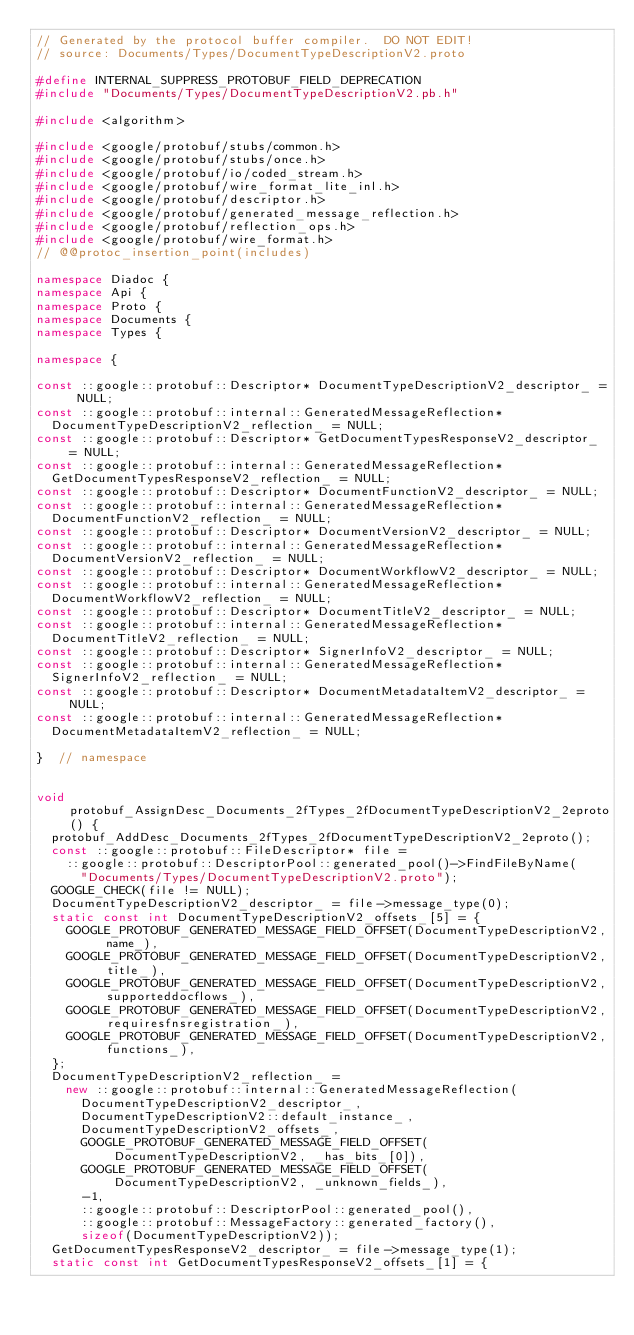Convert code to text. <code><loc_0><loc_0><loc_500><loc_500><_C++_>// Generated by the protocol buffer compiler.  DO NOT EDIT!
// source: Documents/Types/DocumentTypeDescriptionV2.proto

#define INTERNAL_SUPPRESS_PROTOBUF_FIELD_DEPRECATION
#include "Documents/Types/DocumentTypeDescriptionV2.pb.h"

#include <algorithm>

#include <google/protobuf/stubs/common.h>
#include <google/protobuf/stubs/once.h>
#include <google/protobuf/io/coded_stream.h>
#include <google/protobuf/wire_format_lite_inl.h>
#include <google/protobuf/descriptor.h>
#include <google/protobuf/generated_message_reflection.h>
#include <google/protobuf/reflection_ops.h>
#include <google/protobuf/wire_format.h>
// @@protoc_insertion_point(includes)

namespace Diadoc {
namespace Api {
namespace Proto {
namespace Documents {
namespace Types {

namespace {

const ::google::protobuf::Descriptor* DocumentTypeDescriptionV2_descriptor_ = NULL;
const ::google::protobuf::internal::GeneratedMessageReflection*
  DocumentTypeDescriptionV2_reflection_ = NULL;
const ::google::protobuf::Descriptor* GetDocumentTypesResponseV2_descriptor_ = NULL;
const ::google::protobuf::internal::GeneratedMessageReflection*
  GetDocumentTypesResponseV2_reflection_ = NULL;
const ::google::protobuf::Descriptor* DocumentFunctionV2_descriptor_ = NULL;
const ::google::protobuf::internal::GeneratedMessageReflection*
  DocumentFunctionV2_reflection_ = NULL;
const ::google::protobuf::Descriptor* DocumentVersionV2_descriptor_ = NULL;
const ::google::protobuf::internal::GeneratedMessageReflection*
  DocumentVersionV2_reflection_ = NULL;
const ::google::protobuf::Descriptor* DocumentWorkflowV2_descriptor_ = NULL;
const ::google::protobuf::internal::GeneratedMessageReflection*
  DocumentWorkflowV2_reflection_ = NULL;
const ::google::protobuf::Descriptor* DocumentTitleV2_descriptor_ = NULL;
const ::google::protobuf::internal::GeneratedMessageReflection*
  DocumentTitleV2_reflection_ = NULL;
const ::google::protobuf::Descriptor* SignerInfoV2_descriptor_ = NULL;
const ::google::protobuf::internal::GeneratedMessageReflection*
  SignerInfoV2_reflection_ = NULL;
const ::google::protobuf::Descriptor* DocumentMetadataItemV2_descriptor_ = NULL;
const ::google::protobuf::internal::GeneratedMessageReflection*
  DocumentMetadataItemV2_reflection_ = NULL;

}  // namespace


void protobuf_AssignDesc_Documents_2fTypes_2fDocumentTypeDescriptionV2_2eproto() {
  protobuf_AddDesc_Documents_2fTypes_2fDocumentTypeDescriptionV2_2eproto();
  const ::google::protobuf::FileDescriptor* file =
    ::google::protobuf::DescriptorPool::generated_pool()->FindFileByName(
      "Documents/Types/DocumentTypeDescriptionV2.proto");
  GOOGLE_CHECK(file != NULL);
  DocumentTypeDescriptionV2_descriptor_ = file->message_type(0);
  static const int DocumentTypeDescriptionV2_offsets_[5] = {
    GOOGLE_PROTOBUF_GENERATED_MESSAGE_FIELD_OFFSET(DocumentTypeDescriptionV2, name_),
    GOOGLE_PROTOBUF_GENERATED_MESSAGE_FIELD_OFFSET(DocumentTypeDescriptionV2, title_),
    GOOGLE_PROTOBUF_GENERATED_MESSAGE_FIELD_OFFSET(DocumentTypeDescriptionV2, supporteddocflows_),
    GOOGLE_PROTOBUF_GENERATED_MESSAGE_FIELD_OFFSET(DocumentTypeDescriptionV2, requiresfnsregistration_),
    GOOGLE_PROTOBUF_GENERATED_MESSAGE_FIELD_OFFSET(DocumentTypeDescriptionV2, functions_),
  };
  DocumentTypeDescriptionV2_reflection_ =
    new ::google::protobuf::internal::GeneratedMessageReflection(
      DocumentTypeDescriptionV2_descriptor_,
      DocumentTypeDescriptionV2::default_instance_,
      DocumentTypeDescriptionV2_offsets_,
      GOOGLE_PROTOBUF_GENERATED_MESSAGE_FIELD_OFFSET(DocumentTypeDescriptionV2, _has_bits_[0]),
      GOOGLE_PROTOBUF_GENERATED_MESSAGE_FIELD_OFFSET(DocumentTypeDescriptionV2, _unknown_fields_),
      -1,
      ::google::protobuf::DescriptorPool::generated_pool(),
      ::google::protobuf::MessageFactory::generated_factory(),
      sizeof(DocumentTypeDescriptionV2));
  GetDocumentTypesResponseV2_descriptor_ = file->message_type(1);
  static const int GetDocumentTypesResponseV2_offsets_[1] = {</code> 